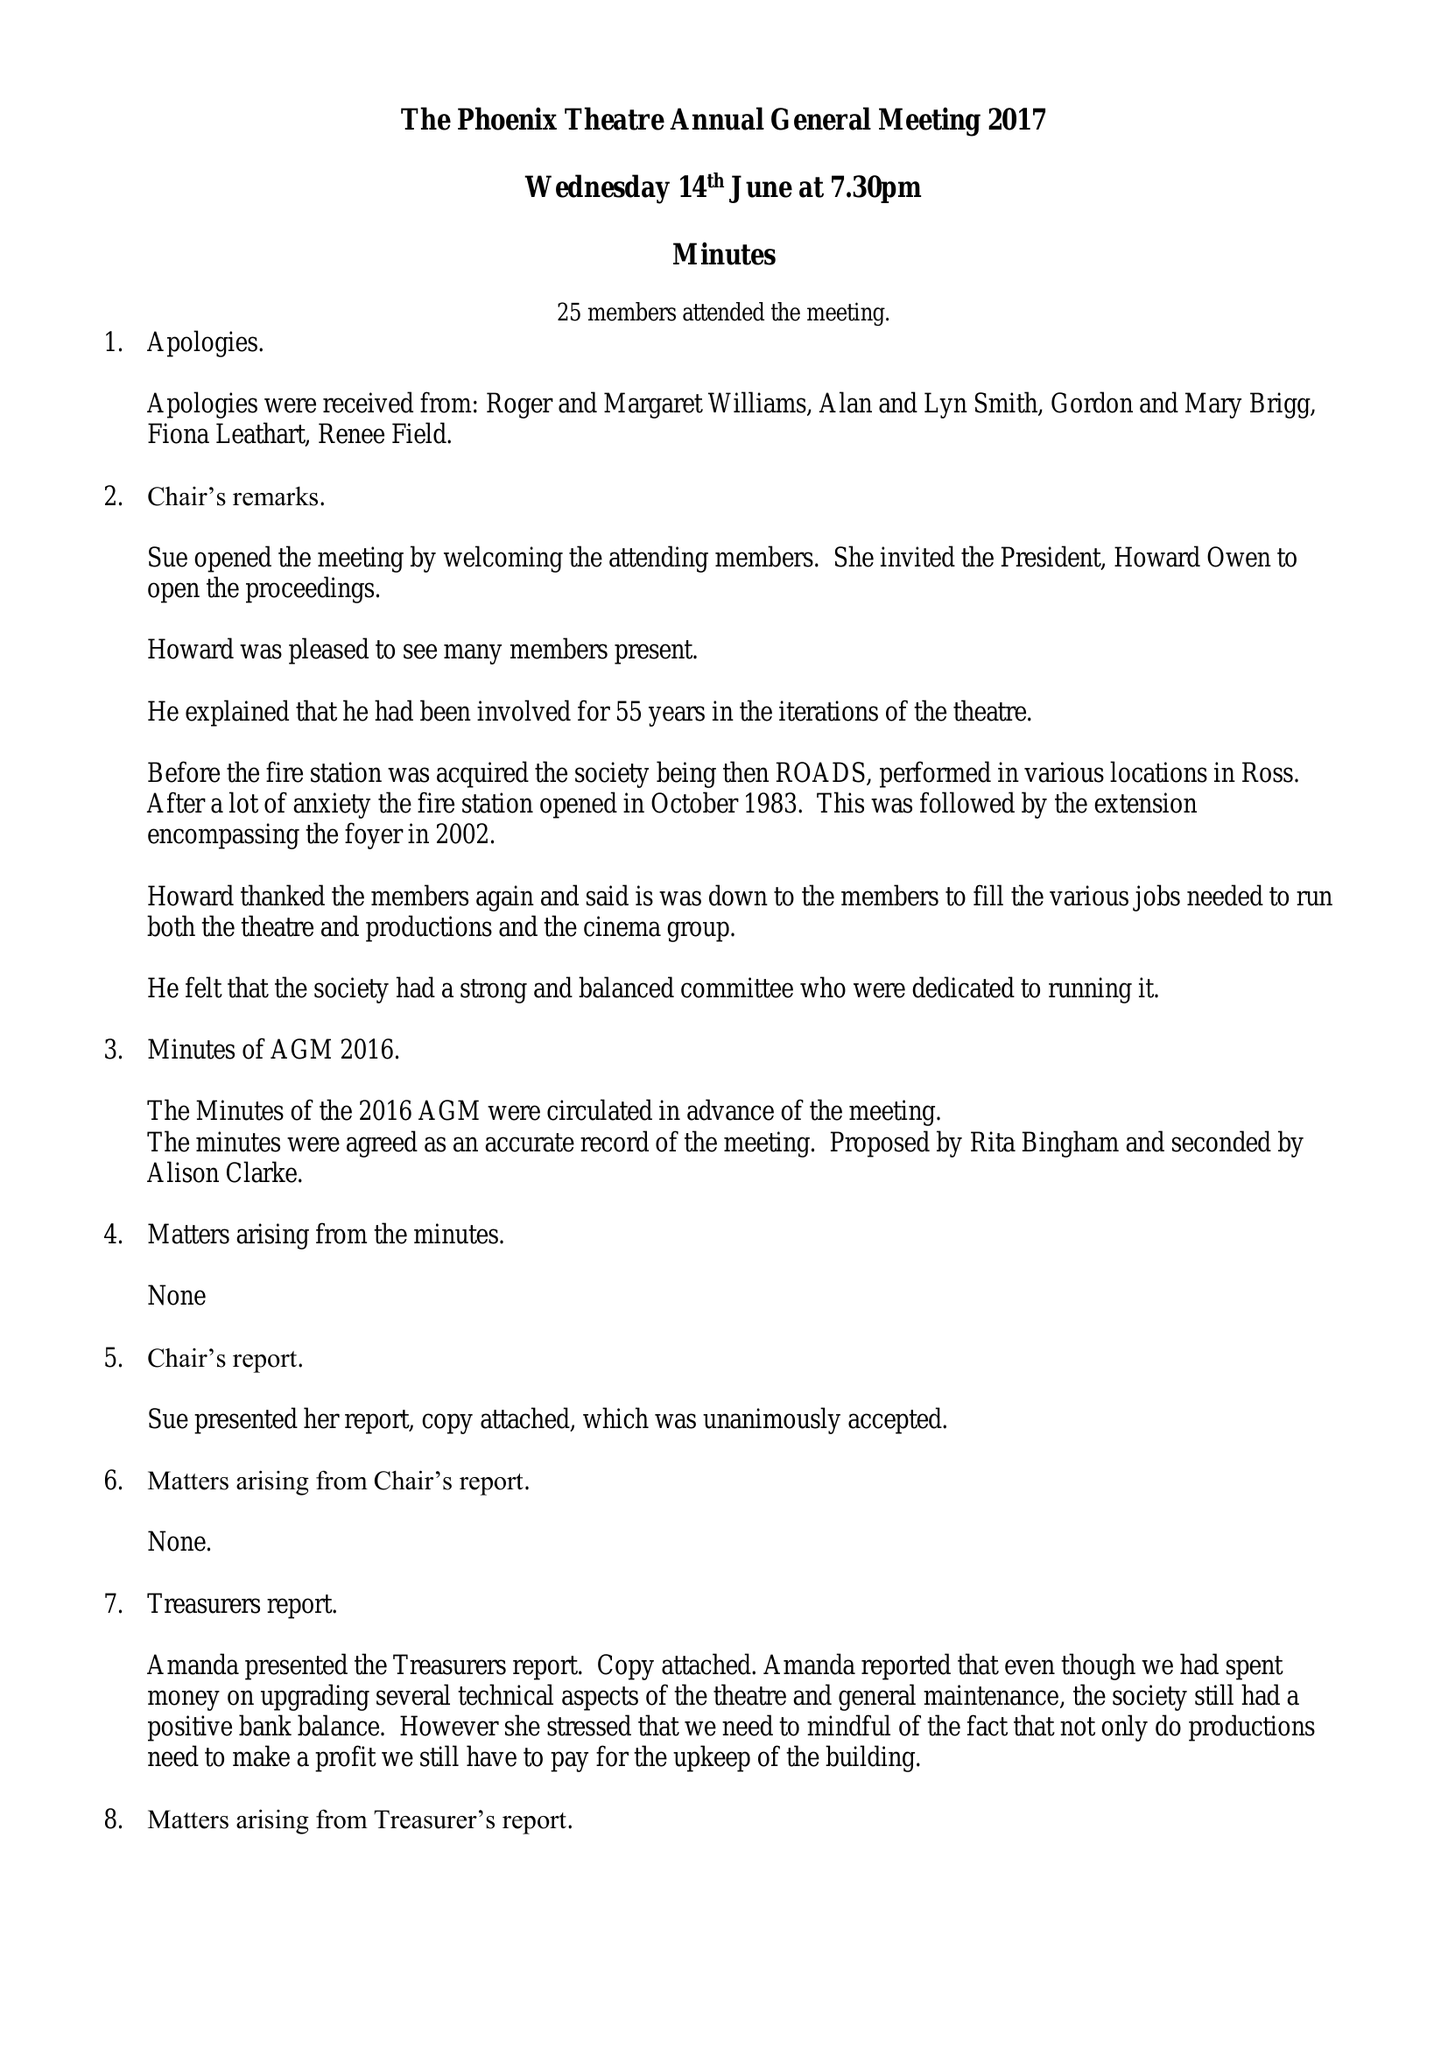What is the value for the address__post_town?
Answer the question using a single word or phrase. ROSS-ON-WYE 